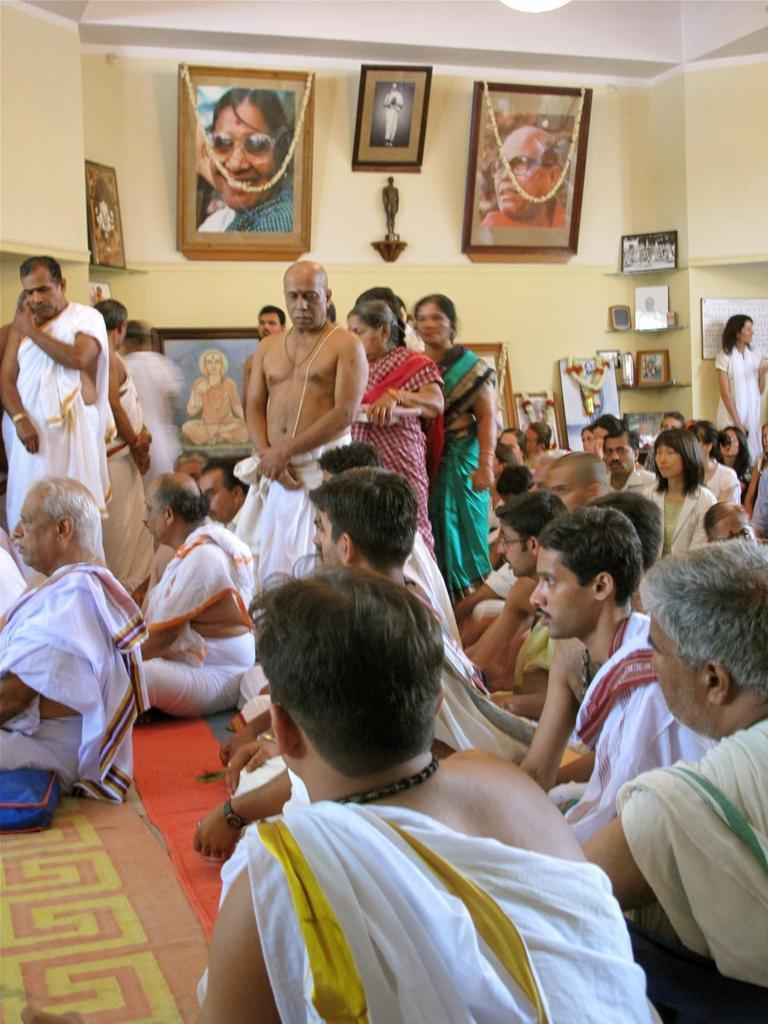What are the people in the image doing? There are people sitting and standing in the image. What can be seen on the wall in the image? There are photos on the wall in the image. Can you describe the wall in the image? There is a wall in the image. What type of scent can be smelled in the image? There is no mention of a scent in the image, so it cannot be determined from the image. 